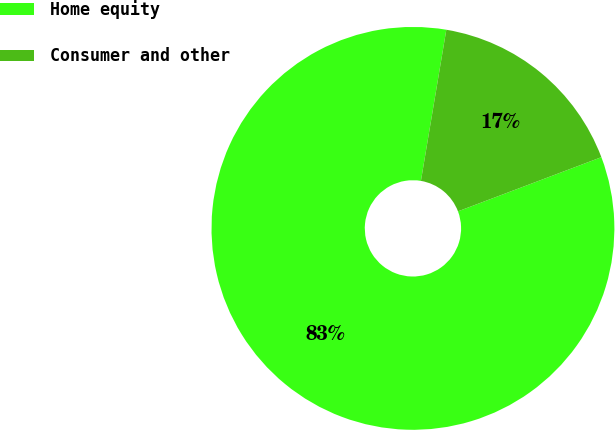<chart> <loc_0><loc_0><loc_500><loc_500><pie_chart><fcel>Home equity<fcel>Consumer and other<nl><fcel>83.4%<fcel>16.6%<nl></chart> 